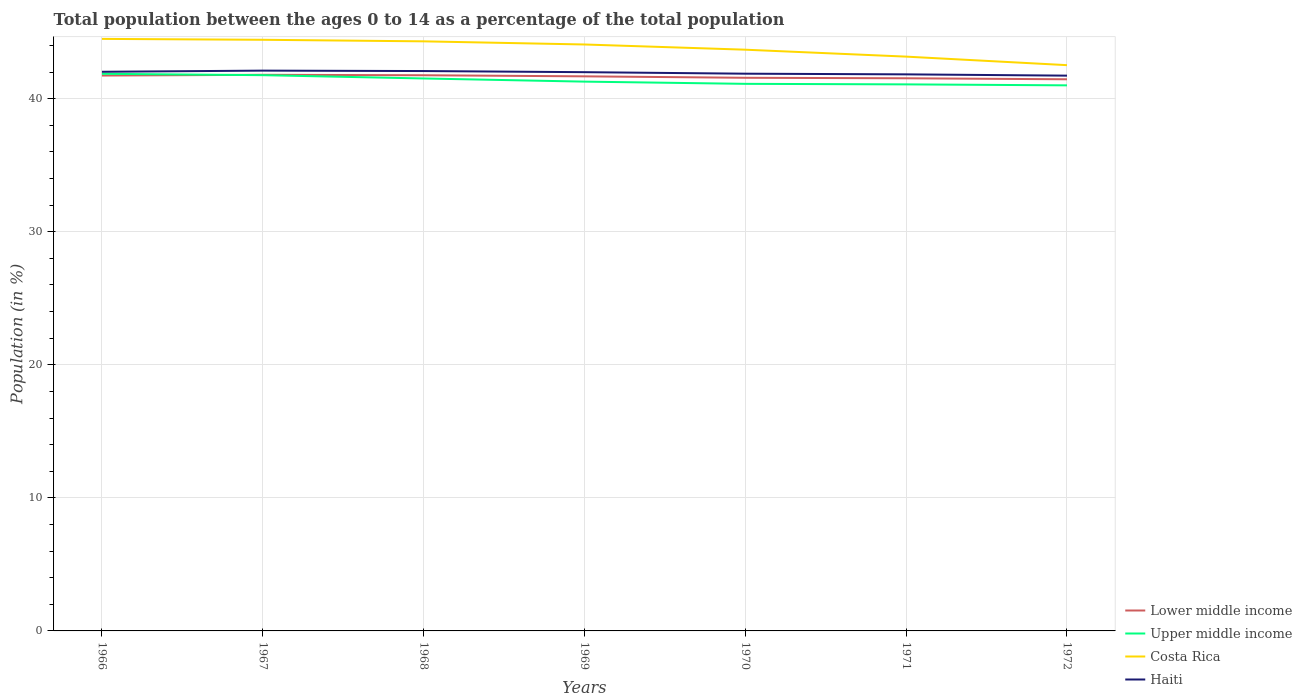How many different coloured lines are there?
Keep it short and to the point. 4. Does the line corresponding to Costa Rica intersect with the line corresponding to Lower middle income?
Make the answer very short. No. Across all years, what is the maximum percentage of the population ages 0 to 14 in Upper middle income?
Your answer should be very brief. 41.01. In which year was the percentage of the population ages 0 to 14 in Costa Rica maximum?
Provide a short and direct response. 1972. What is the total percentage of the population ages 0 to 14 in Costa Rica in the graph?
Ensure brevity in your answer.  0.35. What is the difference between the highest and the second highest percentage of the population ages 0 to 14 in Haiti?
Give a very brief answer. 0.38. What is the difference between the highest and the lowest percentage of the population ages 0 to 14 in Upper middle income?
Keep it short and to the point. 3. Is the percentage of the population ages 0 to 14 in Costa Rica strictly greater than the percentage of the population ages 0 to 14 in Haiti over the years?
Your answer should be very brief. No. How many lines are there?
Your response must be concise. 4. Does the graph contain any zero values?
Your answer should be very brief. No. Does the graph contain grids?
Your response must be concise. Yes. How many legend labels are there?
Keep it short and to the point. 4. How are the legend labels stacked?
Provide a short and direct response. Vertical. What is the title of the graph?
Give a very brief answer. Total population between the ages 0 to 14 as a percentage of the total population. What is the label or title of the Y-axis?
Your answer should be compact. Population (in %). What is the Population (in %) in Lower middle income in 1966?
Your response must be concise. 41.74. What is the Population (in %) in Upper middle income in 1966?
Your answer should be compact. 41.87. What is the Population (in %) of Costa Rica in 1966?
Offer a very short reply. 44.5. What is the Population (in %) in Haiti in 1966?
Your answer should be very brief. 42.03. What is the Population (in %) of Lower middle income in 1967?
Your response must be concise. 41.8. What is the Population (in %) of Upper middle income in 1967?
Provide a short and direct response. 41.77. What is the Population (in %) in Costa Rica in 1967?
Give a very brief answer. 44.43. What is the Population (in %) of Haiti in 1967?
Provide a succinct answer. 42.11. What is the Population (in %) in Lower middle income in 1968?
Your response must be concise. 41.76. What is the Population (in %) of Upper middle income in 1968?
Offer a terse response. 41.52. What is the Population (in %) of Costa Rica in 1968?
Provide a short and direct response. 44.31. What is the Population (in %) of Haiti in 1968?
Your answer should be compact. 42.08. What is the Population (in %) in Lower middle income in 1969?
Provide a succinct answer. 41.68. What is the Population (in %) in Upper middle income in 1969?
Keep it short and to the point. 41.29. What is the Population (in %) of Costa Rica in 1969?
Give a very brief answer. 44.08. What is the Population (in %) in Haiti in 1969?
Make the answer very short. 42. What is the Population (in %) of Lower middle income in 1970?
Give a very brief answer. 41.57. What is the Population (in %) in Upper middle income in 1970?
Your response must be concise. 41.12. What is the Population (in %) of Costa Rica in 1970?
Provide a succinct answer. 43.69. What is the Population (in %) of Haiti in 1970?
Ensure brevity in your answer.  41.88. What is the Population (in %) of Lower middle income in 1971?
Make the answer very short. 41.54. What is the Population (in %) in Upper middle income in 1971?
Make the answer very short. 41.08. What is the Population (in %) in Costa Rica in 1971?
Give a very brief answer. 43.16. What is the Population (in %) in Haiti in 1971?
Your answer should be compact. 41.83. What is the Population (in %) in Lower middle income in 1972?
Your answer should be very brief. 41.46. What is the Population (in %) of Upper middle income in 1972?
Give a very brief answer. 41.01. What is the Population (in %) of Costa Rica in 1972?
Your response must be concise. 42.52. What is the Population (in %) of Haiti in 1972?
Offer a terse response. 41.73. Across all years, what is the maximum Population (in %) in Lower middle income?
Provide a succinct answer. 41.8. Across all years, what is the maximum Population (in %) in Upper middle income?
Keep it short and to the point. 41.87. Across all years, what is the maximum Population (in %) of Costa Rica?
Provide a succinct answer. 44.5. Across all years, what is the maximum Population (in %) of Haiti?
Offer a very short reply. 42.11. Across all years, what is the minimum Population (in %) of Lower middle income?
Provide a succinct answer. 41.46. Across all years, what is the minimum Population (in %) in Upper middle income?
Provide a short and direct response. 41.01. Across all years, what is the minimum Population (in %) in Costa Rica?
Offer a very short reply. 42.52. Across all years, what is the minimum Population (in %) in Haiti?
Offer a very short reply. 41.73. What is the total Population (in %) of Lower middle income in the graph?
Your response must be concise. 291.56. What is the total Population (in %) of Upper middle income in the graph?
Provide a succinct answer. 289.65. What is the total Population (in %) of Costa Rica in the graph?
Your response must be concise. 306.69. What is the total Population (in %) of Haiti in the graph?
Your response must be concise. 293.66. What is the difference between the Population (in %) of Lower middle income in 1966 and that in 1967?
Your answer should be compact. -0.06. What is the difference between the Population (in %) in Upper middle income in 1966 and that in 1967?
Keep it short and to the point. 0.1. What is the difference between the Population (in %) in Costa Rica in 1966 and that in 1967?
Keep it short and to the point. 0.07. What is the difference between the Population (in %) in Haiti in 1966 and that in 1967?
Provide a succinct answer. -0.09. What is the difference between the Population (in %) of Lower middle income in 1966 and that in 1968?
Give a very brief answer. -0.02. What is the difference between the Population (in %) in Upper middle income in 1966 and that in 1968?
Offer a very short reply. 0.35. What is the difference between the Population (in %) of Costa Rica in 1966 and that in 1968?
Keep it short and to the point. 0.18. What is the difference between the Population (in %) of Haiti in 1966 and that in 1968?
Make the answer very short. -0.06. What is the difference between the Population (in %) in Lower middle income in 1966 and that in 1969?
Ensure brevity in your answer.  0.06. What is the difference between the Population (in %) of Upper middle income in 1966 and that in 1969?
Offer a very short reply. 0.59. What is the difference between the Population (in %) of Costa Rica in 1966 and that in 1969?
Give a very brief answer. 0.42. What is the difference between the Population (in %) of Haiti in 1966 and that in 1969?
Make the answer very short. 0.03. What is the difference between the Population (in %) of Lower middle income in 1966 and that in 1970?
Provide a succinct answer. 0.17. What is the difference between the Population (in %) of Upper middle income in 1966 and that in 1970?
Provide a short and direct response. 0.76. What is the difference between the Population (in %) in Costa Rica in 1966 and that in 1970?
Provide a succinct answer. 0.81. What is the difference between the Population (in %) of Haiti in 1966 and that in 1970?
Offer a terse response. 0.14. What is the difference between the Population (in %) of Lower middle income in 1966 and that in 1971?
Make the answer very short. 0.21. What is the difference between the Population (in %) of Upper middle income in 1966 and that in 1971?
Offer a terse response. 0.8. What is the difference between the Population (in %) of Costa Rica in 1966 and that in 1971?
Your answer should be compact. 1.33. What is the difference between the Population (in %) in Haiti in 1966 and that in 1971?
Your response must be concise. 0.19. What is the difference between the Population (in %) in Lower middle income in 1966 and that in 1972?
Ensure brevity in your answer.  0.28. What is the difference between the Population (in %) of Upper middle income in 1966 and that in 1972?
Offer a terse response. 0.87. What is the difference between the Population (in %) of Costa Rica in 1966 and that in 1972?
Keep it short and to the point. 1.97. What is the difference between the Population (in %) of Haiti in 1966 and that in 1972?
Your answer should be compact. 0.29. What is the difference between the Population (in %) in Lower middle income in 1967 and that in 1968?
Keep it short and to the point. 0.03. What is the difference between the Population (in %) in Upper middle income in 1967 and that in 1968?
Make the answer very short. 0.25. What is the difference between the Population (in %) of Costa Rica in 1967 and that in 1968?
Your answer should be very brief. 0.12. What is the difference between the Population (in %) in Haiti in 1967 and that in 1968?
Offer a terse response. 0.03. What is the difference between the Population (in %) in Lower middle income in 1967 and that in 1969?
Keep it short and to the point. 0.12. What is the difference between the Population (in %) in Upper middle income in 1967 and that in 1969?
Give a very brief answer. 0.48. What is the difference between the Population (in %) of Costa Rica in 1967 and that in 1969?
Your answer should be very brief. 0.35. What is the difference between the Population (in %) in Haiti in 1967 and that in 1969?
Keep it short and to the point. 0.12. What is the difference between the Population (in %) of Lower middle income in 1967 and that in 1970?
Offer a very short reply. 0.22. What is the difference between the Population (in %) in Upper middle income in 1967 and that in 1970?
Offer a very short reply. 0.65. What is the difference between the Population (in %) of Costa Rica in 1967 and that in 1970?
Provide a succinct answer. 0.75. What is the difference between the Population (in %) in Haiti in 1967 and that in 1970?
Your answer should be very brief. 0.23. What is the difference between the Population (in %) of Lower middle income in 1967 and that in 1971?
Provide a short and direct response. 0.26. What is the difference between the Population (in %) of Upper middle income in 1967 and that in 1971?
Keep it short and to the point. 0.69. What is the difference between the Population (in %) of Costa Rica in 1967 and that in 1971?
Make the answer very short. 1.27. What is the difference between the Population (in %) of Haiti in 1967 and that in 1971?
Your answer should be compact. 0.28. What is the difference between the Population (in %) in Lower middle income in 1967 and that in 1972?
Give a very brief answer. 0.34. What is the difference between the Population (in %) of Upper middle income in 1967 and that in 1972?
Give a very brief answer. 0.76. What is the difference between the Population (in %) in Costa Rica in 1967 and that in 1972?
Keep it short and to the point. 1.91. What is the difference between the Population (in %) of Haiti in 1967 and that in 1972?
Your answer should be compact. 0.38. What is the difference between the Population (in %) in Lower middle income in 1968 and that in 1969?
Your response must be concise. 0.08. What is the difference between the Population (in %) of Upper middle income in 1968 and that in 1969?
Your response must be concise. 0.24. What is the difference between the Population (in %) in Costa Rica in 1968 and that in 1969?
Ensure brevity in your answer.  0.24. What is the difference between the Population (in %) in Haiti in 1968 and that in 1969?
Your answer should be compact. 0.09. What is the difference between the Population (in %) in Lower middle income in 1968 and that in 1970?
Provide a short and direct response. 0.19. What is the difference between the Population (in %) in Upper middle income in 1968 and that in 1970?
Ensure brevity in your answer.  0.4. What is the difference between the Population (in %) of Costa Rica in 1968 and that in 1970?
Give a very brief answer. 0.63. What is the difference between the Population (in %) of Haiti in 1968 and that in 1970?
Offer a very short reply. 0.2. What is the difference between the Population (in %) of Lower middle income in 1968 and that in 1971?
Your answer should be very brief. 0.23. What is the difference between the Population (in %) of Upper middle income in 1968 and that in 1971?
Your response must be concise. 0.44. What is the difference between the Population (in %) in Costa Rica in 1968 and that in 1971?
Offer a terse response. 1.15. What is the difference between the Population (in %) of Haiti in 1968 and that in 1971?
Make the answer very short. 0.25. What is the difference between the Population (in %) of Lower middle income in 1968 and that in 1972?
Your response must be concise. 0.3. What is the difference between the Population (in %) in Upper middle income in 1968 and that in 1972?
Make the answer very short. 0.52. What is the difference between the Population (in %) of Costa Rica in 1968 and that in 1972?
Keep it short and to the point. 1.79. What is the difference between the Population (in %) in Haiti in 1968 and that in 1972?
Your answer should be compact. 0.35. What is the difference between the Population (in %) of Lower middle income in 1969 and that in 1970?
Keep it short and to the point. 0.11. What is the difference between the Population (in %) in Upper middle income in 1969 and that in 1970?
Ensure brevity in your answer.  0.17. What is the difference between the Population (in %) in Costa Rica in 1969 and that in 1970?
Make the answer very short. 0.39. What is the difference between the Population (in %) in Haiti in 1969 and that in 1970?
Your response must be concise. 0.11. What is the difference between the Population (in %) of Lower middle income in 1969 and that in 1971?
Your answer should be compact. 0.14. What is the difference between the Population (in %) of Upper middle income in 1969 and that in 1971?
Ensure brevity in your answer.  0.21. What is the difference between the Population (in %) in Costa Rica in 1969 and that in 1971?
Offer a very short reply. 0.91. What is the difference between the Population (in %) of Haiti in 1969 and that in 1971?
Provide a short and direct response. 0.16. What is the difference between the Population (in %) of Lower middle income in 1969 and that in 1972?
Offer a very short reply. 0.22. What is the difference between the Population (in %) of Upper middle income in 1969 and that in 1972?
Provide a short and direct response. 0.28. What is the difference between the Population (in %) of Costa Rica in 1969 and that in 1972?
Your answer should be very brief. 1.55. What is the difference between the Population (in %) of Haiti in 1969 and that in 1972?
Make the answer very short. 0.26. What is the difference between the Population (in %) in Lower middle income in 1970 and that in 1971?
Provide a succinct answer. 0.04. What is the difference between the Population (in %) of Costa Rica in 1970 and that in 1971?
Provide a succinct answer. 0.52. What is the difference between the Population (in %) in Haiti in 1970 and that in 1971?
Provide a succinct answer. 0.05. What is the difference between the Population (in %) in Lower middle income in 1970 and that in 1972?
Keep it short and to the point. 0.11. What is the difference between the Population (in %) of Upper middle income in 1970 and that in 1972?
Give a very brief answer. 0.11. What is the difference between the Population (in %) in Costa Rica in 1970 and that in 1972?
Keep it short and to the point. 1.16. What is the difference between the Population (in %) of Haiti in 1970 and that in 1972?
Your answer should be compact. 0.15. What is the difference between the Population (in %) in Lower middle income in 1971 and that in 1972?
Your answer should be compact. 0.08. What is the difference between the Population (in %) in Upper middle income in 1971 and that in 1972?
Your answer should be very brief. 0.07. What is the difference between the Population (in %) of Costa Rica in 1971 and that in 1972?
Ensure brevity in your answer.  0.64. What is the difference between the Population (in %) of Haiti in 1971 and that in 1972?
Your response must be concise. 0.1. What is the difference between the Population (in %) in Lower middle income in 1966 and the Population (in %) in Upper middle income in 1967?
Your answer should be very brief. -0.03. What is the difference between the Population (in %) of Lower middle income in 1966 and the Population (in %) of Costa Rica in 1967?
Provide a succinct answer. -2.69. What is the difference between the Population (in %) in Lower middle income in 1966 and the Population (in %) in Haiti in 1967?
Your answer should be compact. -0.37. What is the difference between the Population (in %) in Upper middle income in 1966 and the Population (in %) in Costa Rica in 1967?
Your response must be concise. -2.56. What is the difference between the Population (in %) in Upper middle income in 1966 and the Population (in %) in Haiti in 1967?
Your response must be concise. -0.24. What is the difference between the Population (in %) of Costa Rica in 1966 and the Population (in %) of Haiti in 1967?
Provide a succinct answer. 2.38. What is the difference between the Population (in %) in Lower middle income in 1966 and the Population (in %) in Upper middle income in 1968?
Offer a very short reply. 0.22. What is the difference between the Population (in %) in Lower middle income in 1966 and the Population (in %) in Costa Rica in 1968?
Offer a terse response. -2.57. What is the difference between the Population (in %) in Lower middle income in 1966 and the Population (in %) in Haiti in 1968?
Offer a very short reply. -0.34. What is the difference between the Population (in %) of Upper middle income in 1966 and the Population (in %) of Costa Rica in 1968?
Give a very brief answer. -2.44. What is the difference between the Population (in %) in Upper middle income in 1966 and the Population (in %) in Haiti in 1968?
Give a very brief answer. -0.21. What is the difference between the Population (in %) in Costa Rica in 1966 and the Population (in %) in Haiti in 1968?
Ensure brevity in your answer.  2.42. What is the difference between the Population (in %) of Lower middle income in 1966 and the Population (in %) of Upper middle income in 1969?
Provide a succinct answer. 0.46. What is the difference between the Population (in %) of Lower middle income in 1966 and the Population (in %) of Costa Rica in 1969?
Give a very brief answer. -2.33. What is the difference between the Population (in %) of Lower middle income in 1966 and the Population (in %) of Haiti in 1969?
Ensure brevity in your answer.  -0.25. What is the difference between the Population (in %) in Upper middle income in 1966 and the Population (in %) in Costa Rica in 1969?
Keep it short and to the point. -2.2. What is the difference between the Population (in %) of Upper middle income in 1966 and the Population (in %) of Haiti in 1969?
Provide a succinct answer. -0.12. What is the difference between the Population (in %) of Costa Rica in 1966 and the Population (in %) of Haiti in 1969?
Give a very brief answer. 2.5. What is the difference between the Population (in %) in Lower middle income in 1966 and the Population (in %) in Upper middle income in 1970?
Your answer should be compact. 0.62. What is the difference between the Population (in %) of Lower middle income in 1966 and the Population (in %) of Costa Rica in 1970?
Provide a succinct answer. -1.94. What is the difference between the Population (in %) of Lower middle income in 1966 and the Population (in %) of Haiti in 1970?
Ensure brevity in your answer.  -0.14. What is the difference between the Population (in %) in Upper middle income in 1966 and the Population (in %) in Costa Rica in 1970?
Provide a succinct answer. -1.81. What is the difference between the Population (in %) of Upper middle income in 1966 and the Population (in %) of Haiti in 1970?
Ensure brevity in your answer.  -0.01. What is the difference between the Population (in %) in Costa Rica in 1966 and the Population (in %) in Haiti in 1970?
Provide a short and direct response. 2.61. What is the difference between the Population (in %) of Lower middle income in 1966 and the Population (in %) of Upper middle income in 1971?
Keep it short and to the point. 0.66. What is the difference between the Population (in %) of Lower middle income in 1966 and the Population (in %) of Costa Rica in 1971?
Offer a terse response. -1.42. What is the difference between the Population (in %) in Lower middle income in 1966 and the Population (in %) in Haiti in 1971?
Your answer should be compact. -0.09. What is the difference between the Population (in %) of Upper middle income in 1966 and the Population (in %) of Costa Rica in 1971?
Your answer should be very brief. -1.29. What is the difference between the Population (in %) in Upper middle income in 1966 and the Population (in %) in Haiti in 1971?
Your answer should be very brief. 0.04. What is the difference between the Population (in %) in Costa Rica in 1966 and the Population (in %) in Haiti in 1971?
Offer a terse response. 2.67. What is the difference between the Population (in %) in Lower middle income in 1966 and the Population (in %) in Upper middle income in 1972?
Provide a succinct answer. 0.74. What is the difference between the Population (in %) in Lower middle income in 1966 and the Population (in %) in Costa Rica in 1972?
Offer a terse response. -0.78. What is the difference between the Population (in %) of Lower middle income in 1966 and the Population (in %) of Haiti in 1972?
Provide a succinct answer. 0.01. What is the difference between the Population (in %) in Upper middle income in 1966 and the Population (in %) in Costa Rica in 1972?
Keep it short and to the point. -0.65. What is the difference between the Population (in %) in Upper middle income in 1966 and the Population (in %) in Haiti in 1972?
Offer a terse response. 0.14. What is the difference between the Population (in %) of Costa Rica in 1966 and the Population (in %) of Haiti in 1972?
Make the answer very short. 2.76. What is the difference between the Population (in %) of Lower middle income in 1967 and the Population (in %) of Upper middle income in 1968?
Your response must be concise. 0.28. What is the difference between the Population (in %) of Lower middle income in 1967 and the Population (in %) of Costa Rica in 1968?
Offer a very short reply. -2.51. What is the difference between the Population (in %) in Lower middle income in 1967 and the Population (in %) in Haiti in 1968?
Your answer should be compact. -0.28. What is the difference between the Population (in %) in Upper middle income in 1967 and the Population (in %) in Costa Rica in 1968?
Provide a short and direct response. -2.54. What is the difference between the Population (in %) in Upper middle income in 1967 and the Population (in %) in Haiti in 1968?
Provide a succinct answer. -0.31. What is the difference between the Population (in %) in Costa Rica in 1967 and the Population (in %) in Haiti in 1968?
Ensure brevity in your answer.  2.35. What is the difference between the Population (in %) of Lower middle income in 1967 and the Population (in %) of Upper middle income in 1969?
Ensure brevity in your answer.  0.51. What is the difference between the Population (in %) of Lower middle income in 1967 and the Population (in %) of Costa Rica in 1969?
Keep it short and to the point. -2.28. What is the difference between the Population (in %) of Lower middle income in 1967 and the Population (in %) of Haiti in 1969?
Your response must be concise. -0.2. What is the difference between the Population (in %) in Upper middle income in 1967 and the Population (in %) in Costa Rica in 1969?
Keep it short and to the point. -2.31. What is the difference between the Population (in %) in Upper middle income in 1967 and the Population (in %) in Haiti in 1969?
Ensure brevity in your answer.  -0.23. What is the difference between the Population (in %) in Costa Rica in 1967 and the Population (in %) in Haiti in 1969?
Ensure brevity in your answer.  2.44. What is the difference between the Population (in %) of Lower middle income in 1967 and the Population (in %) of Upper middle income in 1970?
Your answer should be compact. 0.68. What is the difference between the Population (in %) in Lower middle income in 1967 and the Population (in %) in Costa Rica in 1970?
Offer a terse response. -1.89. What is the difference between the Population (in %) of Lower middle income in 1967 and the Population (in %) of Haiti in 1970?
Provide a short and direct response. -0.08. What is the difference between the Population (in %) of Upper middle income in 1967 and the Population (in %) of Costa Rica in 1970?
Offer a very short reply. -1.92. What is the difference between the Population (in %) of Upper middle income in 1967 and the Population (in %) of Haiti in 1970?
Make the answer very short. -0.11. What is the difference between the Population (in %) of Costa Rica in 1967 and the Population (in %) of Haiti in 1970?
Offer a terse response. 2.55. What is the difference between the Population (in %) in Lower middle income in 1967 and the Population (in %) in Upper middle income in 1971?
Give a very brief answer. 0.72. What is the difference between the Population (in %) in Lower middle income in 1967 and the Population (in %) in Costa Rica in 1971?
Ensure brevity in your answer.  -1.37. What is the difference between the Population (in %) in Lower middle income in 1967 and the Population (in %) in Haiti in 1971?
Offer a terse response. -0.03. What is the difference between the Population (in %) of Upper middle income in 1967 and the Population (in %) of Costa Rica in 1971?
Keep it short and to the point. -1.39. What is the difference between the Population (in %) in Upper middle income in 1967 and the Population (in %) in Haiti in 1971?
Keep it short and to the point. -0.06. What is the difference between the Population (in %) in Costa Rica in 1967 and the Population (in %) in Haiti in 1971?
Your response must be concise. 2.6. What is the difference between the Population (in %) of Lower middle income in 1967 and the Population (in %) of Upper middle income in 1972?
Offer a terse response. 0.79. What is the difference between the Population (in %) of Lower middle income in 1967 and the Population (in %) of Costa Rica in 1972?
Make the answer very short. -0.72. What is the difference between the Population (in %) in Lower middle income in 1967 and the Population (in %) in Haiti in 1972?
Provide a short and direct response. 0.06. What is the difference between the Population (in %) in Upper middle income in 1967 and the Population (in %) in Costa Rica in 1972?
Offer a very short reply. -0.75. What is the difference between the Population (in %) in Upper middle income in 1967 and the Population (in %) in Haiti in 1972?
Your answer should be compact. 0.04. What is the difference between the Population (in %) of Costa Rica in 1967 and the Population (in %) of Haiti in 1972?
Your answer should be compact. 2.7. What is the difference between the Population (in %) in Lower middle income in 1968 and the Population (in %) in Upper middle income in 1969?
Provide a succinct answer. 0.48. What is the difference between the Population (in %) of Lower middle income in 1968 and the Population (in %) of Costa Rica in 1969?
Provide a succinct answer. -2.31. What is the difference between the Population (in %) in Lower middle income in 1968 and the Population (in %) in Haiti in 1969?
Provide a short and direct response. -0.23. What is the difference between the Population (in %) of Upper middle income in 1968 and the Population (in %) of Costa Rica in 1969?
Keep it short and to the point. -2.55. What is the difference between the Population (in %) of Upper middle income in 1968 and the Population (in %) of Haiti in 1969?
Your answer should be compact. -0.47. What is the difference between the Population (in %) in Costa Rica in 1968 and the Population (in %) in Haiti in 1969?
Make the answer very short. 2.32. What is the difference between the Population (in %) in Lower middle income in 1968 and the Population (in %) in Upper middle income in 1970?
Offer a very short reply. 0.65. What is the difference between the Population (in %) in Lower middle income in 1968 and the Population (in %) in Costa Rica in 1970?
Provide a succinct answer. -1.92. What is the difference between the Population (in %) in Lower middle income in 1968 and the Population (in %) in Haiti in 1970?
Give a very brief answer. -0.12. What is the difference between the Population (in %) of Upper middle income in 1968 and the Population (in %) of Costa Rica in 1970?
Provide a succinct answer. -2.16. What is the difference between the Population (in %) of Upper middle income in 1968 and the Population (in %) of Haiti in 1970?
Your answer should be compact. -0.36. What is the difference between the Population (in %) in Costa Rica in 1968 and the Population (in %) in Haiti in 1970?
Offer a very short reply. 2.43. What is the difference between the Population (in %) in Lower middle income in 1968 and the Population (in %) in Upper middle income in 1971?
Provide a succinct answer. 0.69. What is the difference between the Population (in %) in Lower middle income in 1968 and the Population (in %) in Costa Rica in 1971?
Offer a terse response. -1.4. What is the difference between the Population (in %) in Lower middle income in 1968 and the Population (in %) in Haiti in 1971?
Ensure brevity in your answer.  -0.07. What is the difference between the Population (in %) of Upper middle income in 1968 and the Population (in %) of Costa Rica in 1971?
Provide a short and direct response. -1.64. What is the difference between the Population (in %) in Upper middle income in 1968 and the Population (in %) in Haiti in 1971?
Your answer should be compact. -0.31. What is the difference between the Population (in %) in Costa Rica in 1968 and the Population (in %) in Haiti in 1971?
Your response must be concise. 2.48. What is the difference between the Population (in %) in Lower middle income in 1968 and the Population (in %) in Upper middle income in 1972?
Ensure brevity in your answer.  0.76. What is the difference between the Population (in %) of Lower middle income in 1968 and the Population (in %) of Costa Rica in 1972?
Provide a short and direct response. -0.76. What is the difference between the Population (in %) in Lower middle income in 1968 and the Population (in %) in Haiti in 1972?
Offer a terse response. 0.03. What is the difference between the Population (in %) of Upper middle income in 1968 and the Population (in %) of Costa Rica in 1972?
Your answer should be compact. -1. What is the difference between the Population (in %) in Upper middle income in 1968 and the Population (in %) in Haiti in 1972?
Give a very brief answer. -0.21. What is the difference between the Population (in %) in Costa Rica in 1968 and the Population (in %) in Haiti in 1972?
Your answer should be compact. 2.58. What is the difference between the Population (in %) in Lower middle income in 1969 and the Population (in %) in Upper middle income in 1970?
Offer a terse response. 0.56. What is the difference between the Population (in %) in Lower middle income in 1969 and the Population (in %) in Costa Rica in 1970?
Offer a very short reply. -2. What is the difference between the Population (in %) of Upper middle income in 1969 and the Population (in %) of Costa Rica in 1970?
Provide a short and direct response. -2.4. What is the difference between the Population (in %) in Upper middle income in 1969 and the Population (in %) in Haiti in 1970?
Give a very brief answer. -0.6. What is the difference between the Population (in %) of Costa Rica in 1969 and the Population (in %) of Haiti in 1970?
Give a very brief answer. 2.19. What is the difference between the Population (in %) of Lower middle income in 1969 and the Population (in %) of Upper middle income in 1971?
Offer a very short reply. 0.6. What is the difference between the Population (in %) in Lower middle income in 1969 and the Population (in %) in Costa Rica in 1971?
Keep it short and to the point. -1.48. What is the difference between the Population (in %) in Lower middle income in 1969 and the Population (in %) in Haiti in 1971?
Give a very brief answer. -0.15. What is the difference between the Population (in %) of Upper middle income in 1969 and the Population (in %) of Costa Rica in 1971?
Make the answer very short. -1.88. What is the difference between the Population (in %) in Upper middle income in 1969 and the Population (in %) in Haiti in 1971?
Offer a terse response. -0.55. What is the difference between the Population (in %) in Costa Rica in 1969 and the Population (in %) in Haiti in 1971?
Provide a succinct answer. 2.25. What is the difference between the Population (in %) of Lower middle income in 1969 and the Population (in %) of Upper middle income in 1972?
Give a very brief answer. 0.68. What is the difference between the Population (in %) in Lower middle income in 1969 and the Population (in %) in Costa Rica in 1972?
Keep it short and to the point. -0.84. What is the difference between the Population (in %) of Lower middle income in 1969 and the Population (in %) of Haiti in 1972?
Give a very brief answer. -0.05. What is the difference between the Population (in %) in Upper middle income in 1969 and the Population (in %) in Costa Rica in 1972?
Keep it short and to the point. -1.24. What is the difference between the Population (in %) of Upper middle income in 1969 and the Population (in %) of Haiti in 1972?
Your answer should be compact. -0.45. What is the difference between the Population (in %) in Costa Rica in 1969 and the Population (in %) in Haiti in 1972?
Your answer should be very brief. 2.34. What is the difference between the Population (in %) in Lower middle income in 1970 and the Population (in %) in Upper middle income in 1971?
Offer a very short reply. 0.5. What is the difference between the Population (in %) in Lower middle income in 1970 and the Population (in %) in Costa Rica in 1971?
Your answer should be compact. -1.59. What is the difference between the Population (in %) in Lower middle income in 1970 and the Population (in %) in Haiti in 1971?
Offer a very short reply. -0.26. What is the difference between the Population (in %) in Upper middle income in 1970 and the Population (in %) in Costa Rica in 1971?
Offer a very short reply. -2.05. What is the difference between the Population (in %) in Upper middle income in 1970 and the Population (in %) in Haiti in 1971?
Keep it short and to the point. -0.71. What is the difference between the Population (in %) in Costa Rica in 1970 and the Population (in %) in Haiti in 1971?
Make the answer very short. 1.85. What is the difference between the Population (in %) in Lower middle income in 1970 and the Population (in %) in Upper middle income in 1972?
Make the answer very short. 0.57. What is the difference between the Population (in %) of Lower middle income in 1970 and the Population (in %) of Costa Rica in 1972?
Give a very brief answer. -0.95. What is the difference between the Population (in %) of Lower middle income in 1970 and the Population (in %) of Haiti in 1972?
Your answer should be compact. -0.16. What is the difference between the Population (in %) of Upper middle income in 1970 and the Population (in %) of Costa Rica in 1972?
Keep it short and to the point. -1.4. What is the difference between the Population (in %) of Upper middle income in 1970 and the Population (in %) of Haiti in 1972?
Your answer should be compact. -0.62. What is the difference between the Population (in %) in Costa Rica in 1970 and the Population (in %) in Haiti in 1972?
Provide a succinct answer. 1.95. What is the difference between the Population (in %) in Lower middle income in 1971 and the Population (in %) in Upper middle income in 1972?
Make the answer very short. 0.53. What is the difference between the Population (in %) in Lower middle income in 1971 and the Population (in %) in Costa Rica in 1972?
Provide a short and direct response. -0.99. What is the difference between the Population (in %) in Lower middle income in 1971 and the Population (in %) in Haiti in 1972?
Provide a succinct answer. -0.2. What is the difference between the Population (in %) of Upper middle income in 1971 and the Population (in %) of Costa Rica in 1972?
Offer a terse response. -1.44. What is the difference between the Population (in %) of Upper middle income in 1971 and the Population (in %) of Haiti in 1972?
Your response must be concise. -0.66. What is the difference between the Population (in %) of Costa Rica in 1971 and the Population (in %) of Haiti in 1972?
Offer a very short reply. 1.43. What is the average Population (in %) in Lower middle income per year?
Your response must be concise. 41.65. What is the average Population (in %) of Upper middle income per year?
Your answer should be very brief. 41.38. What is the average Population (in %) in Costa Rica per year?
Offer a very short reply. 43.81. What is the average Population (in %) in Haiti per year?
Give a very brief answer. 41.95. In the year 1966, what is the difference between the Population (in %) of Lower middle income and Population (in %) of Upper middle income?
Give a very brief answer. -0.13. In the year 1966, what is the difference between the Population (in %) in Lower middle income and Population (in %) in Costa Rica?
Your answer should be very brief. -2.75. In the year 1966, what is the difference between the Population (in %) in Lower middle income and Population (in %) in Haiti?
Your response must be concise. -0.28. In the year 1966, what is the difference between the Population (in %) in Upper middle income and Population (in %) in Costa Rica?
Offer a very short reply. -2.62. In the year 1966, what is the difference between the Population (in %) in Upper middle income and Population (in %) in Haiti?
Ensure brevity in your answer.  -0.15. In the year 1966, what is the difference between the Population (in %) of Costa Rica and Population (in %) of Haiti?
Your response must be concise. 2.47. In the year 1967, what is the difference between the Population (in %) of Lower middle income and Population (in %) of Upper middle income?
Your answer should be compact. 0.03. In the year 1967, what is the difference between the Population (in %) in Lower middle income and Population (in %) in Costa Rica?
Ensure brevity in your answer.  -2.63. In the year 1967, what is the difference between the Population (in %) of Lower middle income and Population (in %) of Haiti?
Ensure brevity in your answer.  -0.31. In the year 1967, what is the difference between the Population (in %) in Upper middle income and Population (in %) in Costa Rica?
Your response must be concise. -2.66. In the year 1967, what is the difference between the Population (in %) in Upper middle income and Population (in %) in Haiti?
Keep it short and to the point. -0.34. In the year 1967, what is the difference between the Population (in %) in Costa Rica and Population (in %) in Haiti?
Your answer should be very brief. 2.32. In the year 1968, what is the difference between the Population (in %) of Lower middle income and Population (in %) of Upper middle income?
Ensure brevity in your answer.  0.24. In the year 1968, what is the difference between the Population (in %) of Lower middle income and Population (in %) of Costa Rica?
Your answer should be very brief. -2.55. In the year 1968, what is the difference between the Population (in %) of Lower middle income and Population (in %) of Haiti?
Give a very brief answer. -0.32. In the year 1968, what is the difference between the Population (in %) in Upper middle income and Population (in %) in Costa Rica?
Offer a terse response. -2.79. In the year 1968, what is the difference between the Population (in %) of Upper middle income and Population (in %) of Haiti?
Give a very brief answer. -0.56. In the year 1968, what is the difference between the Population (in %) of Costa Rica and Population (in %) of Haiti?
Offer a very short reply. 2.23. In the year 1969, what is the difference between the Population (in %) in Lower middle income and Population (in %) in Upper middle income?
Provide a short and direct response. 0.4. In the year 1969, what is the difference between the Population (in %) of Lower middle income and Population (in %) of Costa Rica?
Provide a short and direct response. -2.39. In the year 1969, what is the difference between the Population (in %) in Lower middle income and Population (in %) in Haiti?
Provide a succinct answer. -0.31. In the year 1969, what is the difference between the Population (in %) of Upper middle income and Population (in %) of Costa Rica?
Give a very brief answer. -2.79. In the year 1969, what is the difference between the Population (in %) in Upper middle income and Population (in %) in Haiti?
Make the answer very short. -0.71. In the year 1969, what is the difference between the Population (in %) of Costa Rica and Population (in %) of Haiti?
Give a very brief answer. 2.08. In the year 1970, what is the difference between the Population (in %) in Lower middle income and Population (in %) in Upper middle income?
Offer a very short reply. 0.46. In the year 1970, what is the difference between the Population (in %) in Lower middle income and Population (in %) in Costa Rica?
Give a very brief answer. -2.11. In the year 1970, what is the difference between the Population (in %) in Lower middle income and Population (in %) in Haiti?
Make the answer very short. -0.31. In the year 1970, what is the difference between the Population (in %) of Upper middle income and Population (in %) of Costa Rica?
Give a very brief answer. -2.57. In the year 1970, what is the difference between the Population (in %) of Upper middle income and Population (in %) of Haiti?
Provide a succinct answer. -0.76. In the year 1970, what is the difference between the Population (in %) of Costa Rica and Population (in %) of Haiti?
Ensure brevity in your answer.  1.8. In the year 1971, what is the difference between the Population (in %) in Lower middle income and Population (in %) in Upper middle income?
Offer a very short reply. 0.46. In the year 1971, what is the difference between the Population (in %) in Lower middle income and Population (in %) in Costa Rica?
Offer a terse response. -1.63. In the year 1971, what is the difference between the Population (in %) of Lower middle income and Population (in %) of Haiti?
Give a very brief answer. -0.29. In the year 1971, what is the difference between the Population (in %) in Upper middle income and Population (in %) in Costa Rica?
Offer a very short reply. -2.09. In the year 1971, what is the difference between the Population (in %) in Upper middle income and Population (in %) in Haiti?
Your answer should be very brief. -0.75. In the year 1971, what is the difference between the Population (in %) of Costa Rica and Population (in %) of Haiti?
Offer a terse response. 1.33. In the year 1972, what is the difference between the Population (in %) of Lower middle income and Population (in %) of Upper middle income?
Provide a succinct answer. 0.46. In the year 1972, what is the difference between the Population (in %) of Lower middle income and Population (in %) of Costa Rica?
Your answer should be very brief. -1.06. In the year 1972, what is the difference between the Population (in %) in Lower middle income and Population (in %) in Haiti?
Ensure brevity in your answer.  -0.27. In the year 1972, what is the difference between the Population (in %) in Upper middle income and Population (in %) in Costa Rica?
Your answer should be very brief. -1.52. In the year 1972, what is the difference between the Population (in %) in Upper middle income and Population (in %) in Haiti?
Provide a short and direct response. -0.73. In the year 1972, what is the difference between the Population (in %) of Costa Rica and Population (in %) of Haiti?
Offer a very short reply. 0.79. What is the ratio of the Population (in %) of Lower middle income in 1966 to that in 1967?
Provide a short and direct response. 1. What is the ratio of the Population (in %) of Upper middle income in 1966 to that in 1968?
Ensure brevity in your answer.  1.01. What is the ratio of the Population (in %) of Costa Rica in 1966 to that in 1968?
Keep it short and to the point. 1. What is the ratio of the Population (in %) of Haiti in 1966 to that in 1968?
Your answer should be very brief. 1. What is the ratio of the Population (in %) in Lower middle income in 1966 to that in 1969?
Keep it short and to the point. 1. What is the ratio of the Population (in %) of Upper middle income in 1966 to that in 1969?
Keep it short and to the point. 1.01. What is the ratio of the Population (in %) of Costa Rica in 1966 to that in 1969?
Offer a terse response. 1.01. What is the ratio of the Population (in %) in Lower middle income in 1966 to that in 1970?
Ensure brevity in your answer.  1. What is the ratio of the Population (in %) of Upper middle income in 1966 to that in 1970?
Provide a short and direct response. 1.02. What is the ratio of the Population (in %) in Costa Rica in 1966 to that in 1970?
Provide a succinct answer. 1.02. What is the ratio of the Population (in %) of Lower middle income in 1966 to that in 1971?
Your answer should be compact. 1. What is the ratio of the Population (in %) of Upper middle income in 1966 to that in 1971?
Your response must be concise. 1.02. What is the ratio of the Population (in %) of Costa Rica in 1966 to that in 1971?
Ensure brevity in your answer.  1.03. What is the ratio of the Population (in %) in Haiti in 1966 to that in 1971?
Offer a terse response. 1. What is the ratio of the Population (in %) of Lower middle income in 1966 to that in 1972?
Give a very brief answer. 1.01. What is the ratio of the Population (in %) in Upper middle income in 1966 to that in 1972?
Offer a very short reply. 1.02. What is the ratio of the Population (in %) of Costa Rica in 1966 to that in 1972?
Keep it short and to the point. 1.05. What is the ratio of the Population (in %) in Haiti in 1966 to that in 1972?
Your answer should be very brief. 1.01. What is the ratio of the Population (in %) of Upper middle income in 1967 to that in 1968?
Your response must be concise. 1.01. What is the ratio of the Population (in %) in Haiti in 1967 to that in 1968?
Your response must be concise. 1. What is the ratio of the Population (in %) in Upper middle income in 1967 to that in 1969?
Make the answer very short. 1.01. What is the ratio of the Population (in %) of Haiti in 1967 to that in 1969?
Offer a terse response. 1. What is the ratio of the Population (in %) in Lower middle income in 1967 to that in 1970?
Offer a terse response. 1.01. What is the ratio of the Population (in %) of Upper middle income in 1967 to that in 1970?
Make the answer very short. 1.02. What is the ratio of the Population (in %) in Costa Rica in 1967 to that in 1970?
Keep it short and to the point. 1.02. What is the ratio of the Population (in %) in Haiti in 1967 to that in 1970?
Offer a terse response. 1.01. What is the ratio of the Population (in %) in Lower middle income in 1967 to that in 1971?
Your response must be concise. 1.01. What is the ratio of the Population (in %) of Upper middle income in 1967 to that in 1971?
Your answer should be compact. 1.02. What is the ratio of the Population (in %) of Costa Rica in 1967 to that in 1971?
Provide a short and direct response. 1.03. What is the ratio of the Population (in %) in Haiti in 1967 to that in 1971?
Your answer should be compact. 1.01. What is the ratio of the Population (in %) of Upper middle income in 1967 to that in 1972?
Offer a terse response. 1.02. What is the ratio of the Population (in %) in Costa Rica in 1967 to that in 1972?
Offer a terse response. 1.04. What is the ratio of the Population (in %) in Haiti in 1967 to that in 1972?
Offer a terse response. 1.01. What is the ratio of the Population (in %) of Upper middle income in 1968 to that in 1969?
Your answer should be very brief. 1.01. What is the ratio of the Population (in %) of Costa Rica in 1968 to that in 1969?
Make the answer very short. 1.01. What is the ratio of the Population (in %) of Haiti in 1968 to that in 1969?
Provide a short and direct response. 1. What is the ratio of the Population (in %) in Lower middle income in 1968 to that in 1970?
Give a very brief answer. 1. What is the ratio of the Population (in %) of Upper middle income in 1968 to that in 1970?
Provide a short and direct response. 1.01. What is the ratio of the Population (in %) in Costa Rica in 1968 to that in 1970?
Provide a succinct answer. 1.01. What is the ratio of the Population (in %) in Haiti in 1968 to that in 1970?
Offer a terse response. 1. What is the ratio of the Population (in %) of Upper middle income in 1968 to that in 1971?
Ensure brevity in your answer.  1.01. What is the ratio of the Population (in %) in Costa Rica in 1968 to that in 1971?
Make the answer very short. 1.03. What is the ratio of the Population (in %) in Haiti in 1968 to that in 1971?
Ensure brevity in your answer.  1.01. What is the ratio of the Population (in %) of Lower middle income in 1968 to that in 1972?
Make the answer very short. 1.01. What is the ratio of the Population (in %) in Upper middle income in 1968 to that in 1972?
Your answer should be very brief. 1.01. What is the ratio of the Population (in %) of Costa Rica in 1968 to that in 1972?
Make the answer very short. 1.04. What is the ratio of the Population (in %) of Haiti in 1968 to that in 1972?
Offer a very short reply. 1.01. What is the ratio of the Population (in %) in Lower middle income in 1969 to that in 1970?
Ensure brevity in your answer.  1. What is the ratio of the Population (in %) in Costa Rica in 1969 to that in 1970?
Give a very brief answer. 1.01. What is the ratio of the Population (in %) of Lower middle income in 1969 to that in 1971?
Provide a short and direct response. 1. What is the ratio of the Population (in %) in Costa Rica in 1969 to that in 1971?
Offer a very short reply. 1.02. What is the ratio of the Population (in %) in Haiti in 1969 to that in 1971?
Your answer should be very brief. 1. What is the ratio of the Population (in %) in Lower middle income in 1969 to that in 1972?
Offer a terse response. 1.01. What is the ratio of the Population (in %) in Upper middle income in 1969 to that in 1972?
Keep it short and to the point. 1.01. What is the ratio of the Population (in %) of Costa Rica in 1969 to that in 1972?
Your response must be concise. 1.04. What is the ratio of the Population (in %) of Lower middle income in 1970 to that in 1971?
Offer a very short reply. 1. What is the ratio of the Population (in %) in Upper middle income in 1970 to that in 1971?
Offer a terse response. 1. What is the ratio of the Population (in %) of Costa Rica in 1970 to that in 1971?
Provide a succinct answer. 1.01. What is the ratio of the Population (in %) of Upper middle income in 1970 to that in 1972?
Ensure brevity in your answer.  1. What is the ratio of the Population (in %) in Costa Rica in 1970 to that in 1972?
Offer a very short reply. 1.03. What is the ratio of the Population (in %) of Upper middle income in 1971 to that in 1972?
Provide a succinct answer. 1. What is the ratio of the Population (in %) in Costa Rica in 1971 to that in 1972?
Offer a terse response. 1.02. What is the difference between the highest and the second highest Population (in %) of Lower middle income?
Offer a terse response. 0.03. What is the difference between the highest and the second highest Population (in %) of Upper middle income?
Your answer should be compact. 0.1. What is the difference between the highest and the second highest Population (in %) of Costa Rica?
Provide a short and direct response. 0.07. What is the difference between the highest and the second highest Population (in %) in Haiti?
Make the answer very short. 0.03. What is the difference between the highest and the lowest Population (in %) in Lower middle income?
Provide a short and direct response. 0.34. What is the difference between the highest and the lowest Population (in %) of Upper middle income?
Your answer should be compact. 0.87. What is the difference between the highest and the lowest Population (in %) of Costa Rica?
Offer a terse response. 1.97. What is the difference between the highest and the lowest Population (in %) of Haiti?
Provide a short and direct response. 0.38. 